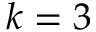Convert formula to latex. <formula><loc_0><loc_0><loc_500><loc_500>k = 3</formula> 